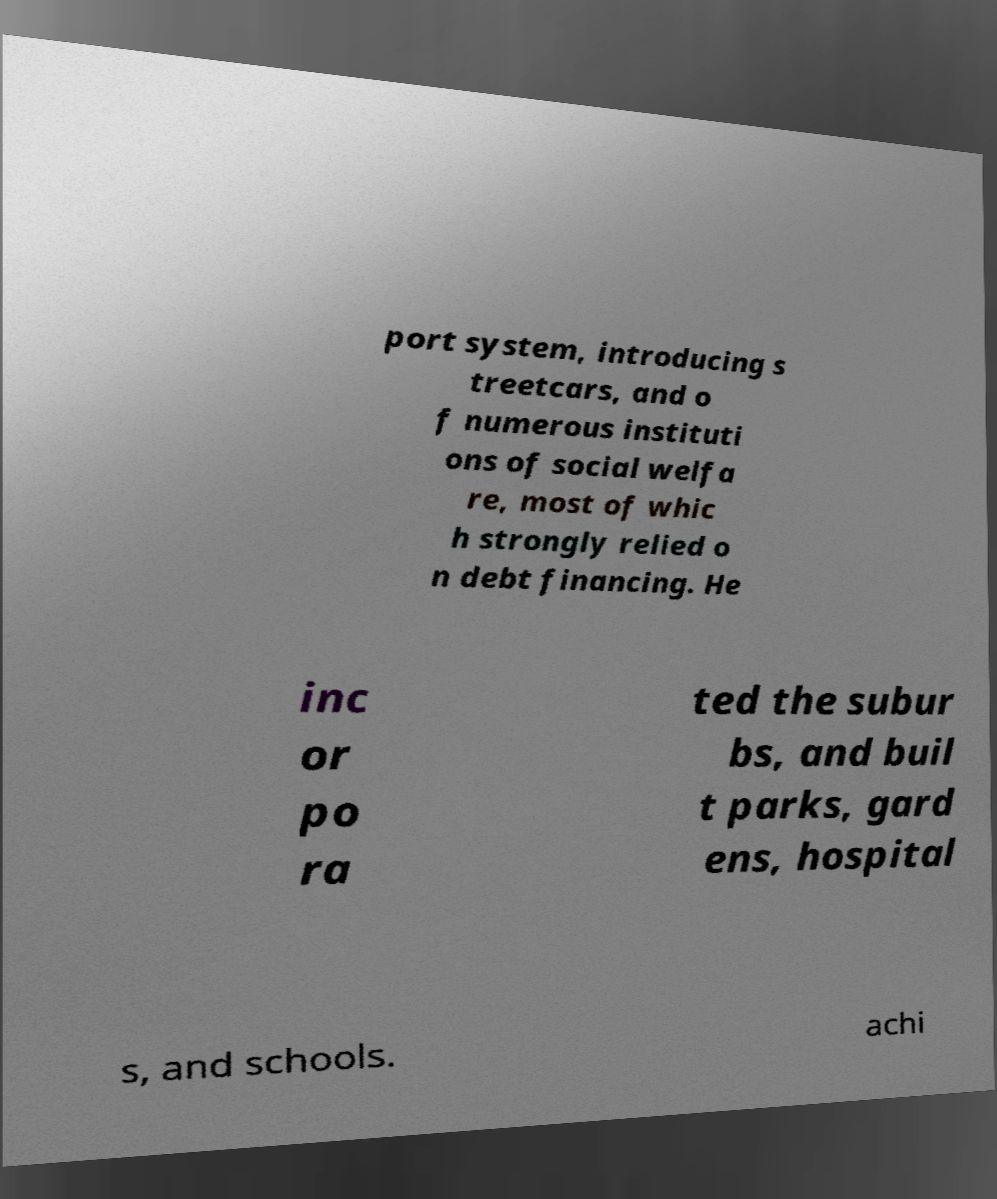Could you assist in decoding the text presented in this image and type it out clearly? port system, introducing s treetcars, and o f numerous instituti ons of social welfa re, most of whic h strongly relied o n debt financing. He inc or po ra ted the subur bs, and buil t parks, gard ens, hospital s, and schools. achi 